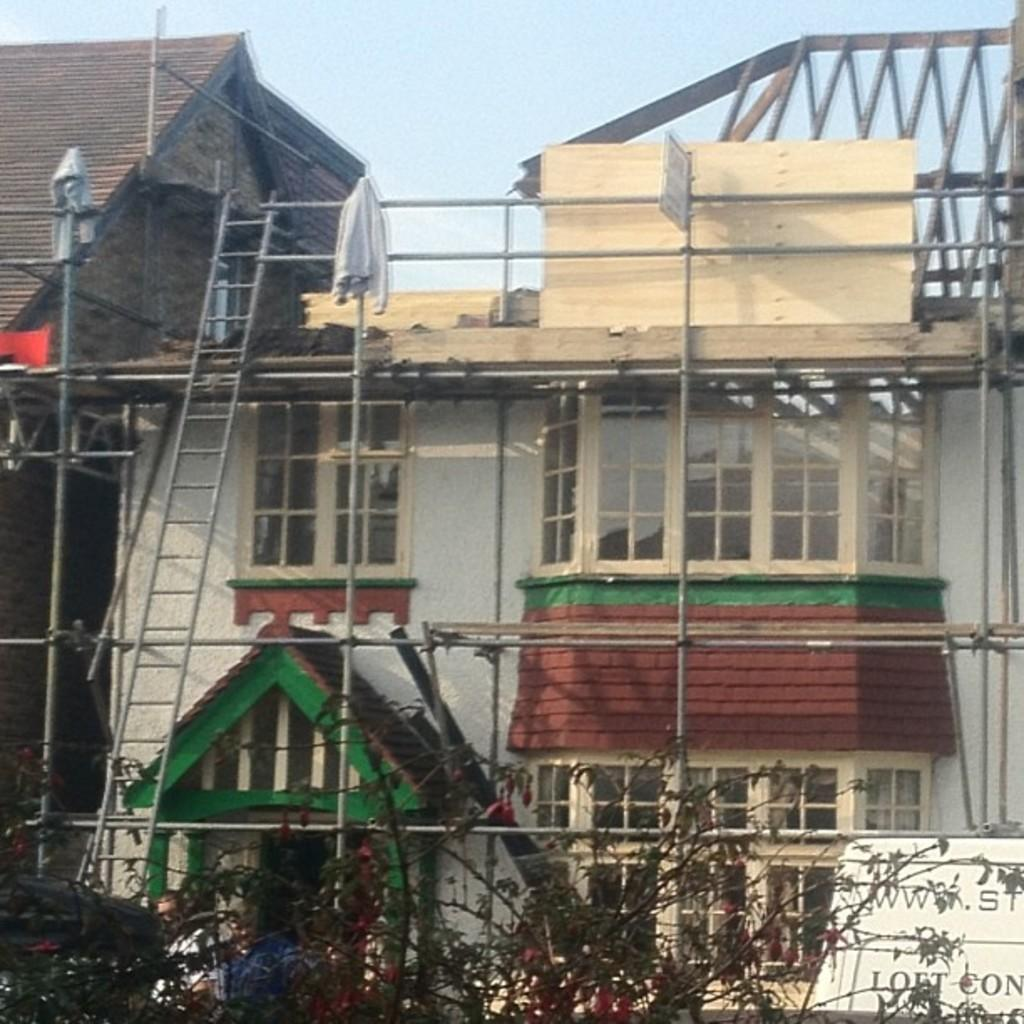What is the main structure in the center of the image? There is a building in the center of the image. What features can be observed on the building? The building has windows, a roof, and a wall visible. What objects are present in the image besides the building? There are poles, trees, jackets, a banner, a sign board, a ladder, a fence, and the sky is visible in the background. Can you tell me how many cans are visible in the image? There are no cans present in the image. Is there a lake visible in the image? There is no lake present in the image. 